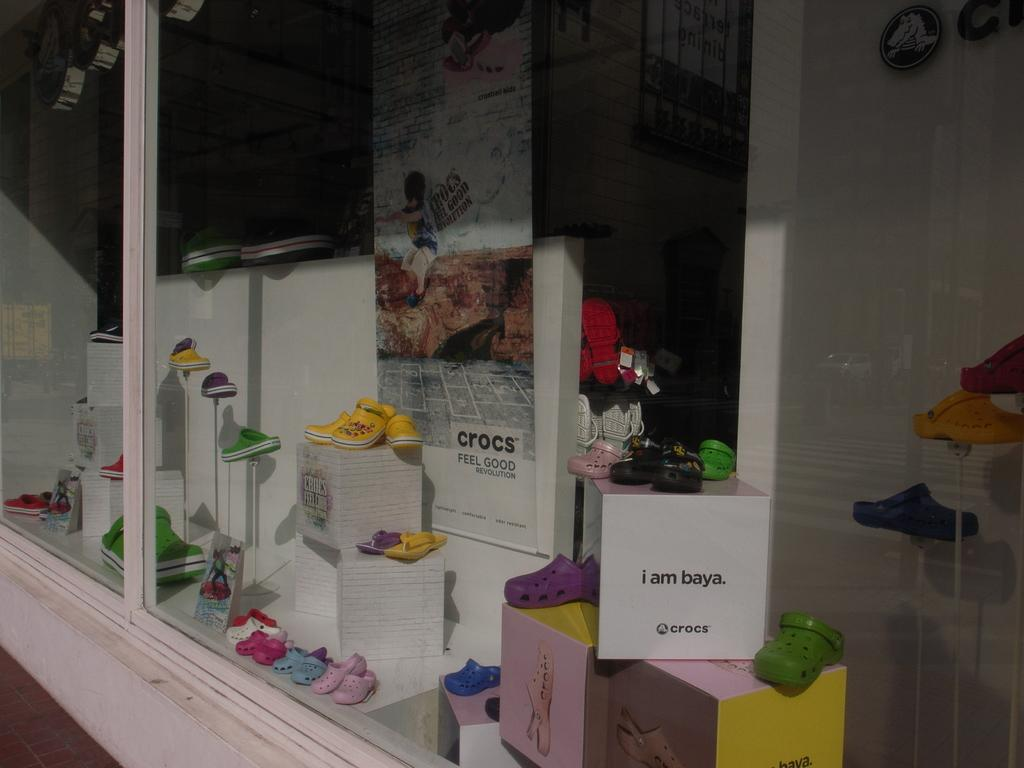Provide a one-sentence caption for the provided image. A display of different colored Crocs shoes and various slogans, including "i am baya.". 